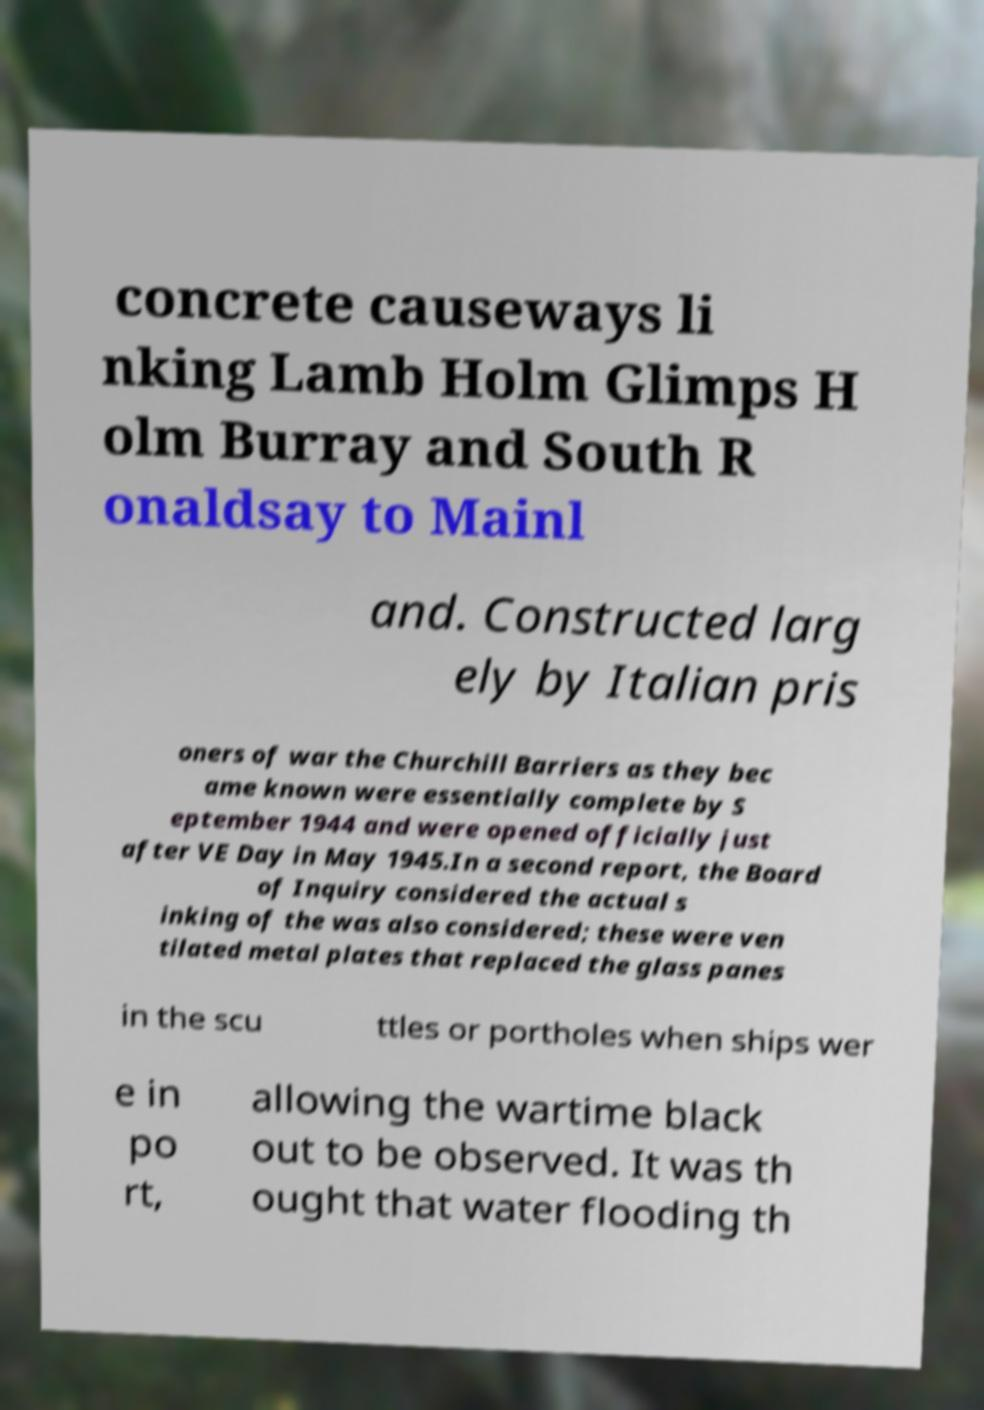Please read and relay the text visible in this image. What does it say? concrete causeways li nking Lamb Holm Glimps H olm Burray and South R onaldsay to Mainl and. Constructed larg ely by Italian pris oners of war the Churchill Barriers as they bec ame known were essentially complete by S eptember 1944 and were opened officially just after VE Day in May 1945.In a second report, the Board of Inquiry considered the actual s inking of the was also considered; these were ven tilated metal plates that replaced the glass panes in the scu ttles or portholes when ships wer e in po rt, allowing the wartime black out to be observed. It was th ought that water flooding th 